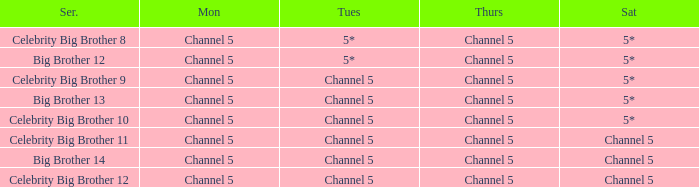Which series airs Saturday on Channel 5? Celebrity Big Brother 11, Big Brother 14, Celebrity Big Brother 12. 